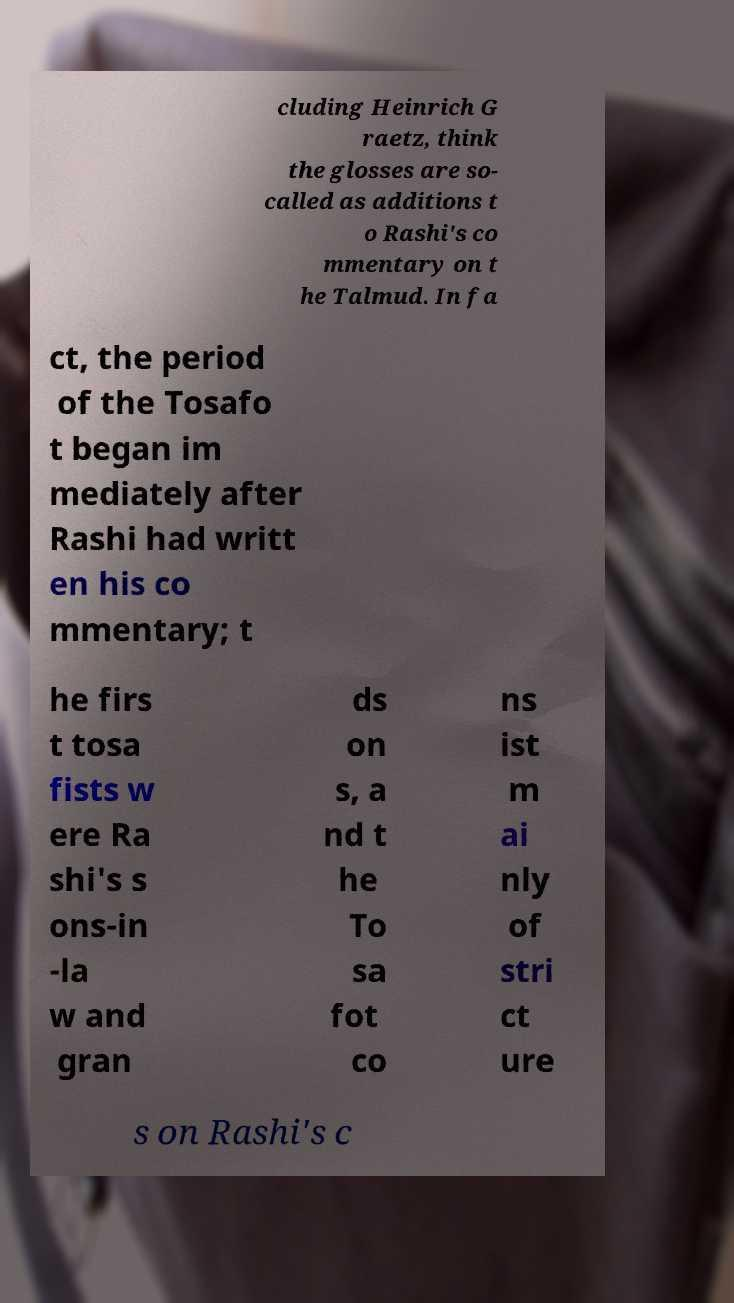Can you read and provide the text displayed in the image?This photo seems to have some interesting text. Can you extract and type it out for me? cluding Heinrich G raetz, think the glosses are so- called as additions t o Rashi's co mmentary on t he Talmud. In fa ct, the period of the Tosafo t began im mediately after Rashi had writt en his co mmentary; t he firs t tosa fists w ere Ra shi's s ons-in -la w and gran ds on s, a nd t he To sa fot co ns ist m ai nly of stri ct ure s on Rashi's c 